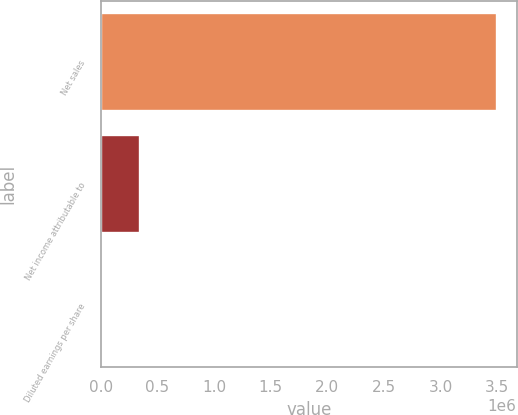<chart> <loc_0><loc_0><loc_500><loc_500><bar_chart><fcel>Net sales<fcel>Net income attributable to<fcel>Diluted earnings per share<nl><fcel>3.49624e+06<fcel>349626<fcel>2.15<nl></chart> 